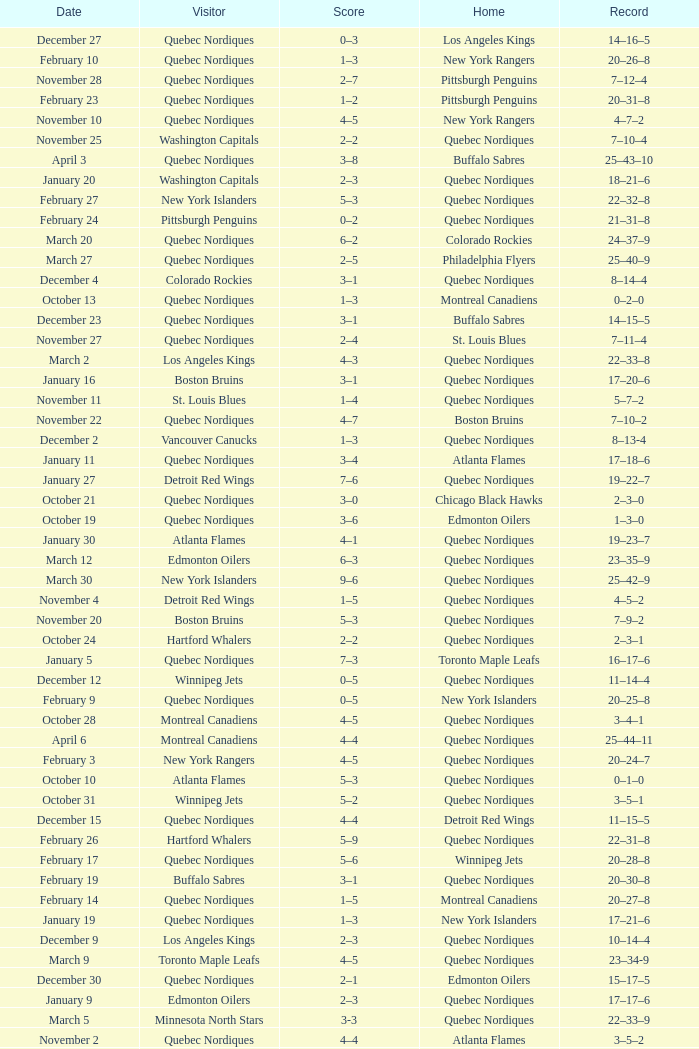Which Record has a Score of 2–4, and a Home of quebec nordiques? 7–8–2. 